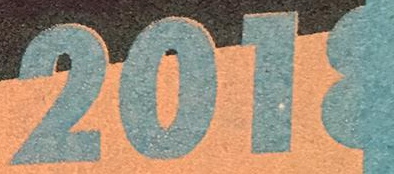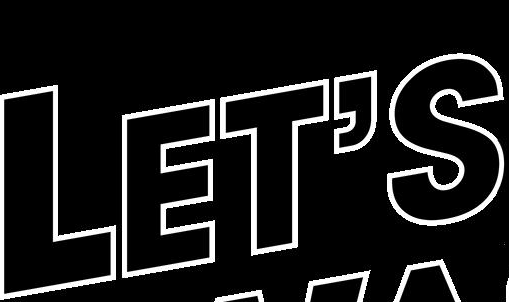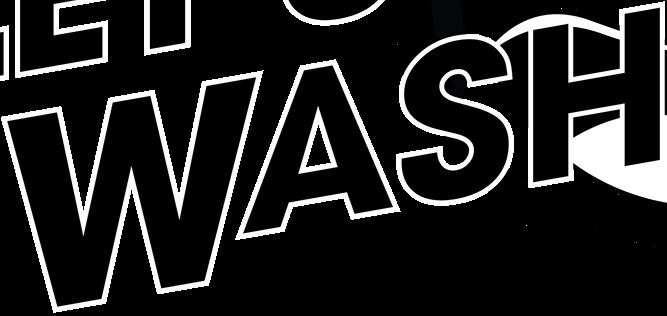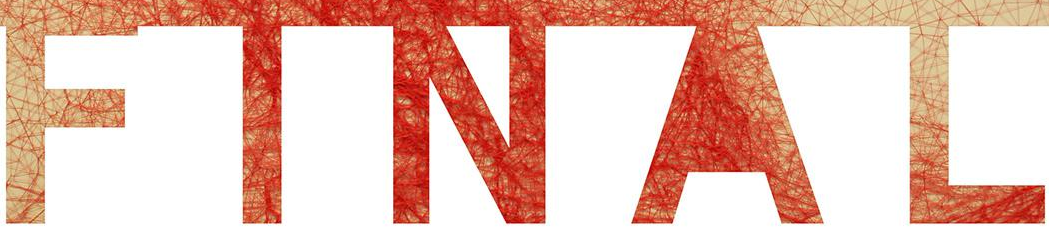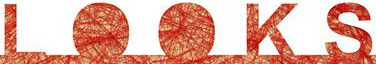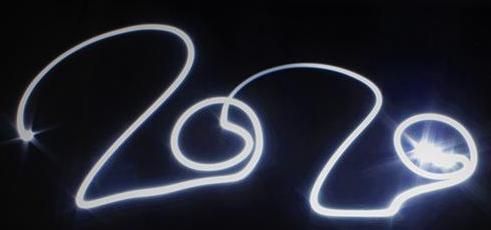Read the text from these images in sequence, separated by a semicolon. 2018; LET'S; WASH; FINAL; LOOKS; 2020 